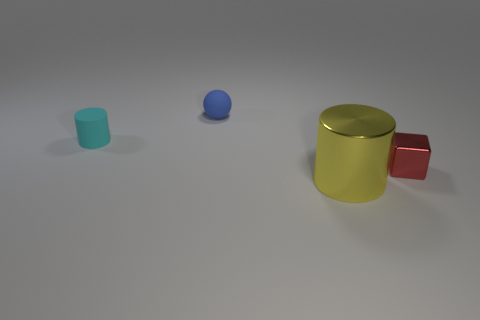Is there a metallic object of the same color as the cube?
Provide a short and direct response. No. What is the size of the cylinder on the right side of the cyan matte object?
Ensure brevity in your answer.  Large. How many other objects are there of the same material as the blue sphere?
Ensure brevity in your answer.  1. Are there any blue rubber spheres that are behind the cylinder behind the small red shiny object?
Your answer should be compact. Yes. Is there anything else that has the same shape as the small red metal thing?
Provide a succinct answer. No. The small object that is the same shape as the large object is what color?
Ensure brevity in your answer.  Cyan. How big is the yellow object?
Provide a short and direct response. Large. Is the number of small cyan things that are on the right side of the tiny rubber ball less than the number of tiny cylinders?
Offer a very short reply. Yes. Do the big cylinder and the thing that is on the left side of the tiny blue rubber thing have the same material?
Make the answer very short. No. There is a cylinder in front of the shiny block to the right of the blue matte object; are there any big cylinders behind it?
Offer a very short reply. No. 